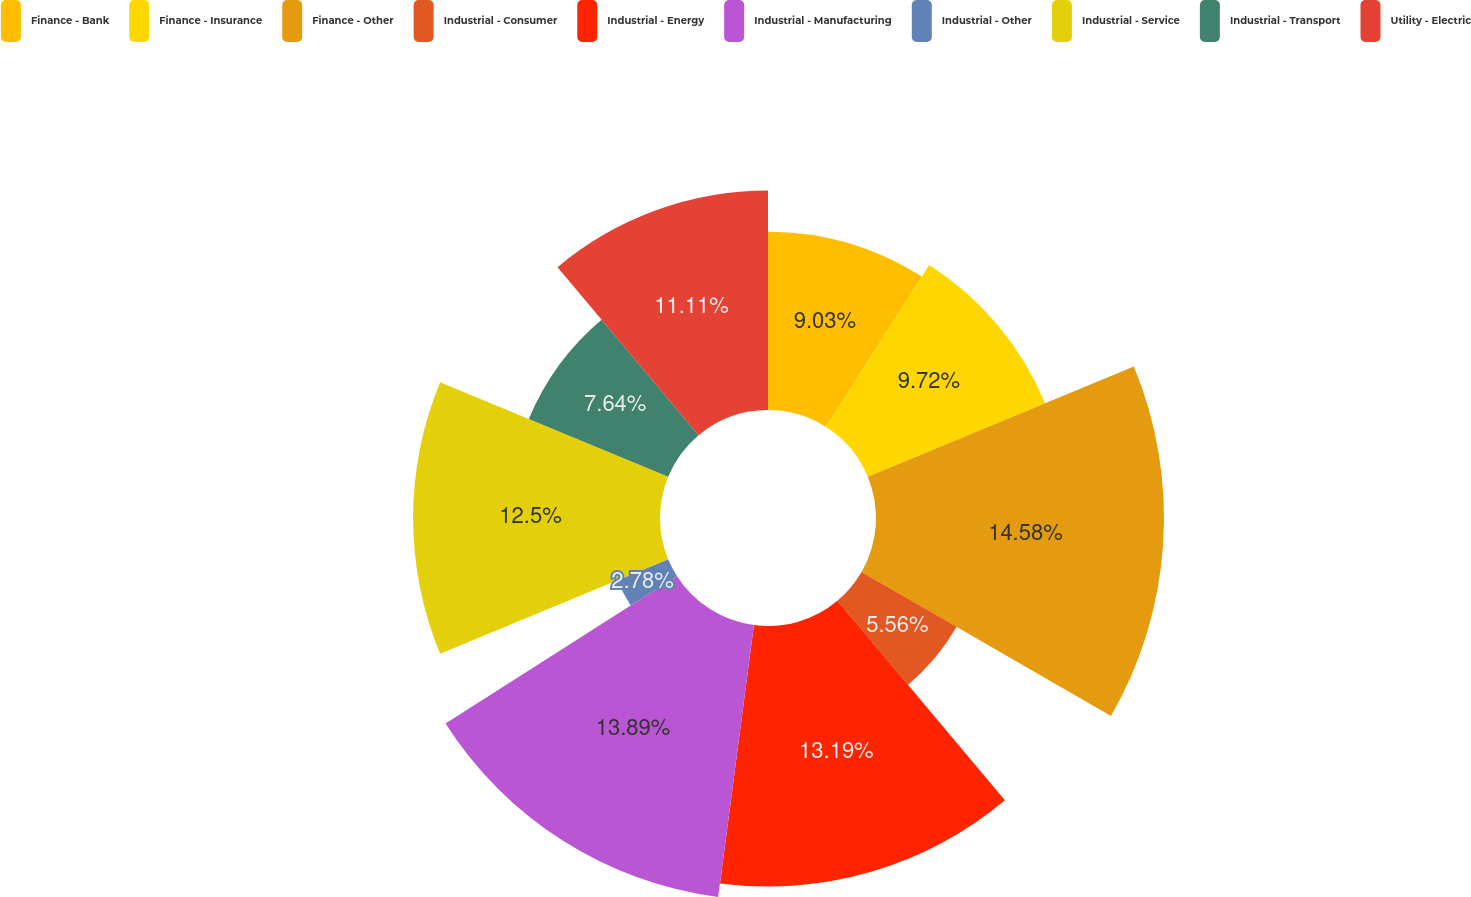<chart> <loc_0><loc_0><loc_500><loc_500><pie_chart><fcel>Finance - Bank<fcel>Finance - Insurance<fcel>Finance - Other<fcel>Industrial - Consumer<fcel>Industrial - Energy<fcel>Industrial - Manufacturing<fcel>Industrial - Other<fcel>Industrial - Service<fcel>Industrial - Transport<fcel>Utility - Electric<nl><fcel>9.03%<fcel>9.72%<fcel>14.58%<fcel>5.56%<fcel>13.19%<fcel>13.89%<fcel>2.78%<fcel>12.5%<fcel>7.64%<fcel>11.11%<nl></chart> 